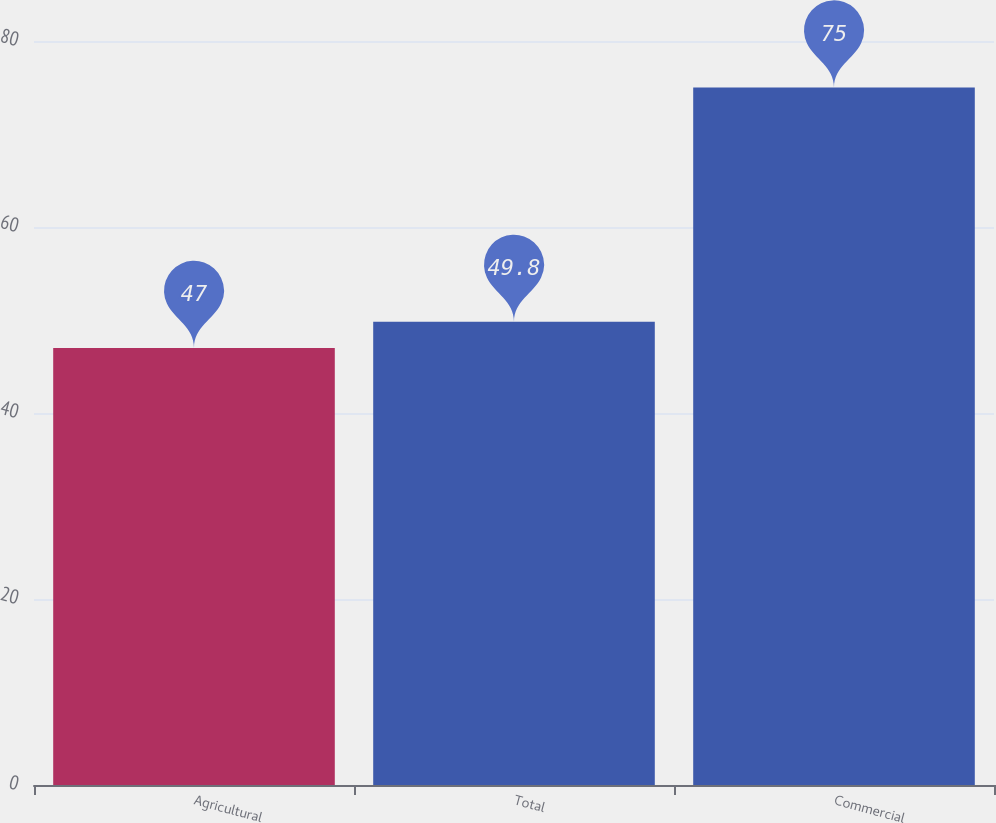Convert chart to OTSL. <chart><loc_0><loc_0><loc_500><loc_500><bar_chart><fcel>Agricultural<fcel>Total<fcel>Commercial<nl><fcel>47<fcel>49.8<fcel>75<nl></chart> 